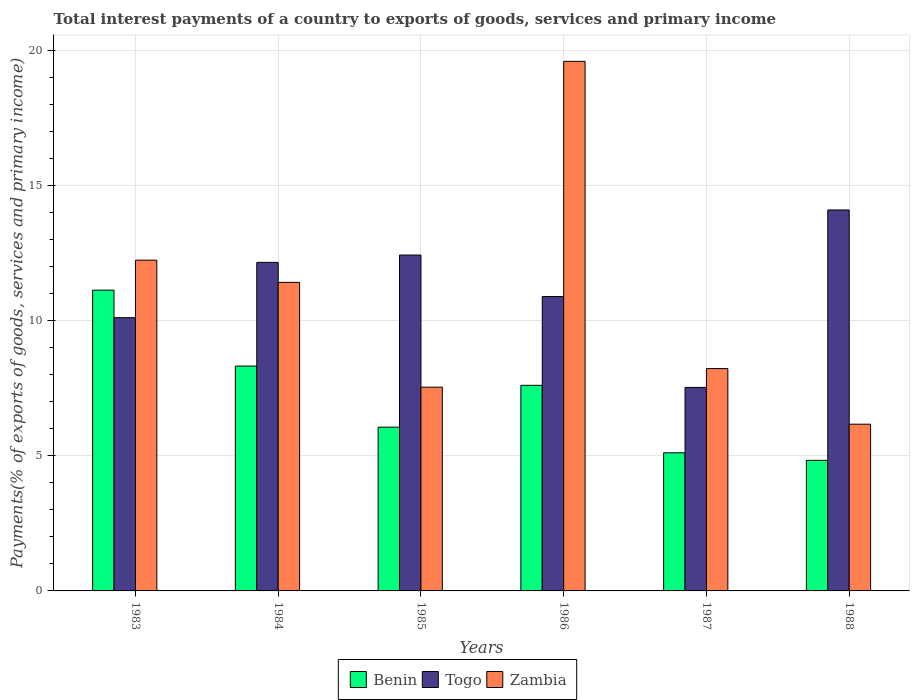How many different coloured bars are there?
Your answer should be compact. 3. Are the number of bars on each tick of the X-axis equal?
Your response must be concise. Yes. How many bars are there on the 4th tick from the left?
Give a very brief answer. 3. How many bars are there on the 4th tick from the right?
Provide a succinct answer. 3. In how many cases, is the number of bars for a given year not equal to the number of legend labels?
Ensure brevity in your answer.  0. What is the total interest payments in Zambia in 1983?
Your answer should be very brief. 12.25. Across all years, what is the maximum total interest payments in Togo?
Keep it short and to the point. 14.1. Across all years, what is the minimum total interest payments in Togo?
Offer a terse response. 7.53. In which year was the total interest payments in Zambia minimum?
Keep it short and to the point. 1988. What is the total total interest payments in Togo in the graph?
Make the answer very short. 67.25. What is the difference between the total interest payments in Zambia in 1986 and that in 1988?
Ensure brevity in your answer.  13.43. What is the difference between the total interest payments in Togo in 1988 and the total interest payments in Benin in 1985?
Keep it short and to the point. 8.04. What is the average total interest payments in Benin per year?
Provide a short and direct response. 7.18. In the year 1988, what is the difference between the total interest payments in Togo and total interest payments in Zambia?
Offer a terse response. 7.93. What is the ratio of the total interest payments in Zambia in 1983 to that in 1984?
Make the answer very short. 1.07. What is the difference between the highest and the second highest total interest payments in Zambia?
Ensure brevity in your answer.  7.36. What is the difference between the highest and the lowest total interest payments in Zambia?
Provide a succinct answer. 13.43. What does the 2nd bar from the left in 1983 represents?
Provide a short and direct response. Togo. What does the 3rd bar from the right in 1985 represents?
Make the answer very short. Benin. How many bars are there?
Ensure brevity in your answer.  18. Are all the bars in the graph horizontal?
Your answer should be very brief. No. What is the difference between two consecutive major ticks on the Y-axis?
Offer a very short reply. 5. Are the values on the major ticks of Y-axis written in scientific E-notation?
Give a very brief answer. No. Does the graph contain any zero values?
Provide a short and direct response. No. Does the graph contain grids?
Offer a very short reply. Yes. Where does the legend appear in the graph?
Your response must be concise. Bottom center. How many legend labels are there?
Your answer should be very brief. 3. How are the legend labels stacked?
Your answer should be compact. Horizontal. What is the title of the graph?
Your answer should be compact. Total interest payments of a country to exports of goods, services and primary income. Does "Latin America(developing only)" appear as one of the legend labels in the graph?
Keep it short and to the point. No. What is the label or title of the Y-axis?
Your answer should be very brief. Payments(% of exports of goods, services and primary income). What is the Payments(% of exports of goods, services and primary income) in Benin in 1983?
Offer a very short reply. 11.14. What is the Payments(% of exports of goods, services and primary income) in Togo in 1983?
Your answer should be very brief. 10.12. What is the Payments(% of exports of goods, services and primary income) of Zambia in 1983?
Keep it short and to the point. 12.25. What is the Payments(% of exports of goods, services and primary income) of Benin in 1984?
Provide a short and direct response. 8.33. What is the Payments(% of exports of goods, services and primary income) in Togo in 1984?
Provide a short and direct response. 12.16. What is the Payments(% of exports of goods, services and primary income) of Zambia in 1984?
Give a very brief answer. 11.42. What is the Payments(% of exports of goods, services and primary income) of Benin in 1985?
Give a very brief answer. 6.06. What is the Payments(% of exports of goods, services and primary income) in Togo in 1985?
Provide a short and direct response. 12.44. What is the Payments(% of exports of goods, services and primary income) in Zambia in 1985?
Ensure brevity in your answer.  7.54. What is the Payments(% of exports of goods, services and primary income) in Benin in 1986?
Your answer should be very brief. 7.61. What is the Payments(% of exports of goods, services and primary income) of Togo in 1986?
Your answer should be very brief. 10.9. What is the Payments(% of exports of goods, services and primary income) in Zambia in 1986?
Offer a very short reply. 19.61. What is the Payments(% of exports of goods, services and primary income) in Benin in 1987?
Give a very brief answer. 5.11. What is the Payments(% of exports of goods, services and primary income) of Togo in 1987?
Your answer should be very brief. 7.53. What is the Payments(% of exports of goods, services and primary income) of Zambia in 1987?
Your response must be concise. 8.23. What is the Payments(% of exports of goods, services and primary income) of Benin in 1988?
Your answer should be very brief. 4.83. What is the Payments(% of exports of goods, services and primary income) of Togo in 1988?
Offer a terse response. 14.1. What is the Payments(% of exports of goods, services and primary income) in Zambia in 1988?
Keep it short and to the point. 6.17. Across all years, what is the maximum Payments(% of exports of goods, services and primary income) of Benin?
Ensure brevity in your answer.  11.14. Across all years, what is the maximum Payments(% of exports of goods, services and primary income) in Togo?
Provide a succinct answer. 14.1. Across all years, what is the maximum Payments(% of exports of goods, services and primary income) in Zambia?
Provide a short and direct response. 19.61. Across all years, what is the minimum Payments(% of exports of goods, services and primary income) of Benin?
Keep it short and to the point. 4.83. Across all years, what is the minimum Payments(% of exports of goods, services and primary income) in Togo?
Give a very brief answer. 7.53. Across all years, what is the minimum Payments(% of exports of goods, services and primary income) of Zambia?
Ensure brevity in your answer.  6.17. What is the total Payments(% of exports of goods, services and primary income) in Benin in the graph?
Ensure brevity in your answer.  43.08. What is the total Payments(% of exports of goods, services and primary income) of Togo in the graph?
Your response must be concise. 67.25. What is the total Payments(% of exports of goods, services and primary income) of Zambia in the graph?
Your response must be concise. 65.22. What is the difference between the Payments(% of exports of goods, services and primary income) in Benin in 1983 and that in 1984?
Provide a succinct answer. 2.81. What is the difference between the Payments(% of exports of goods, services and primary income) of Togo in 1983 and that in 1984?
Provide a short and direct response. -2.05. What is the difference between the Payments(% of exports of goods, services and primary income) in Zambia in 1983 and that in 1984?
Offer a terse response. 0.82. What is the difference between the Payments(% of exports of goods, services and primary income) in Benin in 1983 and that in 1985?
Your response must be concise. 5.07. What is the difference between the Payments(% of exports of goods, services and primary income) of Togo in 1983 and that in 1985?
Make the answer very short. -2.32. What is the difference between the Payments(% of exports of goods, services and primary income) of Zambia in 1983 and that in 1985?
Give a very brief answer. 4.7. What is the difference between the Payments(% of exports of goods, services and primary income) in Benin in 1983 and that in 1986?
Make the answer very short. 3.52. What is the difference between the Payments(% of exports of goods, services and primary income) in Togo in 1983 and that in 1986?
Make the answer very short. -0.78. What is the difference between the Payments(% of exports of goods, services and primary income) of Zambia in 1983 and that in 1986?
Ensure brevity in your answer.  -7.36. What is the difference between the Payments(% of exports of goods, services and primary income) of Benin in 1983 and that in 1987?
Offer a very short reply. 6.02. What is the difference between the Payments(% of exports of goods, services and primary income) in Togo in 1983 and that in 1987?
Provide a succinct answer. 2.58. What is the difference between the Payments(% of exports of goods, services and primary income) in Zambia in 1983 and that in 1987?
Provide a short and direct response. 4.01. What is the difference between the Payments(% of exports of goods, services and primary income) of Benin in 1983 and that in 1988?
Provide a succinct answer. 6.3. What is the difference between the Payments(% of exports of goods, services and primary income) in Togo in 1983 and that in 1988?
Your answer should be very brief. -3.99. What is the difference between the Payments(% of exports of goods, services and primary income) of Zambia in 1983 and that in 1988?
Your response must be concise. 6.07. What is the difference between the Payments(% of exports of goods, services and primary income) in Benin in 1984 and that in 1985?
Your answer should be compact. 2.26. What is the difference between the Payments(% of exports of goods, services and primary income) in Togo in 1984 and that in 1985?
Keep it short and to the point. -0.27. What is the difference between the Payments(% of exports of goods, services and primary income) in Zambia in 1984 and that in 1985?
Offer a terse response. 3.88. What is the difference between the Payments(% of exports of goods, services and primary income) of Benin in 1984 and that in 1986?
Your answer should be very brief. 0.71. What is the difference between the Payments(% of exports of goods, services and primary income) of Togo in 1984 and that in 1986?
Ensure brevity in your answer.  1.27. What is the difference between the Payments(% of exports of goods, services and primary income) of Zambia in 1984 and that in 1986?
Your answer should be very brief. -8.18. What is the difference between the Payments(% of exports of goods, services and primary income) in Benin in 1984 and that in 1987?
Your answer should be compact. 3.21. What is the difference between the Payments(% of exports of goods, services and primary income) in Togo in 1984 and that in 1987?
Provide a succinct answer. 4.63. What is the difference between the Payments(% of exports of goods, services and primary income) of Zambia in 1984 and that in 1987?
Your answer should be compact. 3.19. What is the difference between the Payments(% of exports of goods, services and primary income) of Benin in 1984 and that in 1988?
Provide a short and direct response. 3.49. What is the difference between the Payments(% of exports of goods, services and primary income) of Togo in 1984 and that in 1988?
Keep it short and to the point. -1.94. What is the difference between the Payments(% of exports of goods, services and primary income) of Zambia in 1984 and that in 1988?
Offer a terse response. 5.25. What is the difference between the Payments(% of exports of goods, services and primary income) in Benin in 1985 and that in 1986?
Make the answer very short. -1.55. What is the difference between the Payments(% of exports of goods, services and primary income) of Togo in 1985 and that in 1986?
Ensure brevity in your answer.  1.54. What is the difference between the Payments(% of exports of goods, services and primary income) in Zambia in 1985 and that in 1986?
Offer a terse response. -12.06. What is the difference between the Payments(% of exports of goods, services and primary income) of Benin in 1985 and that in 1987?
Your answer should be very brief. 0.95. What is the difference between the Payments(% of exports of goods, services and primary income) in Togo in 1985 and that in 1987?
Give a very brief answer. 4.9. What is the difference between the Payments(% of exports of goods, services and primary income) of Zambia in 1985 and that in 1987?
Keep it short and to the point. -0.69. What is the difference between the Payments(% of exports of goods, services and primary income) of Benin in 1985 and that in 1988?
Your answer should be very brief. 1.23. What is the difference between the Payments(% of exports of goods, services and primary income) in Togo in 1985 and that in 1988?
Offer a very short reply. -1.67. What is the difference between the Payments(% of exports of goods, services and primary income) of Zambia in 1985 and that in 1988?
Your answer should be compact. 1.37. What is the difference between the Payments(% of exports of goods, services and primary income) of Benin in 1986 and that in 1987?
Your answer should be compact. 2.5. What is the difference between the Payments(% of exports of goods, services and primary income) of Togo in 1986 and that in 1987?
Offer a terse response. 3.36. What is the difference between the Payments(% of exports of goods, services and primary income) of Zambia in 1986 and that in 1987?
Give a very brief answer. 11.37. What is the difference between the Payments(% of exports of goods, services and primary income) of Benin in 1986 and that in 1988?
Provide a succinct answer. 2.78. What is the difference between the Payments(% of exports of goods, services and primary income) in Togo in 1986 and that in 1988?
Your answer should be very brief. -3.21. What is the difference between the Payments(% of exports of goods, services and primary income) in Zambia in 1986 and that in 1988?
Give a very brief answer. 13.43. What is the difference between the Payments(% of exports of goods, services and primary income) in Benin in 1987 and that in 1988?
Your answer should be compact. 0.28. What is the difference between the Payments(% of exports of goods, services and primary income) in Togo in 1987 and that in 1988?
Keep it short and to the point. -6.57. What is the difference between the Payments(% of exports of goods, services and primary income) of Zambia in 1987 and that in 1988?
Make the answer very short. 2.06. What is the difference between the Payments(% of exports of goods, services and primary income) of Benin in 1983 and the Payments(% of exports of goods, services and primary income) of Togo in 1984?
Your answer should be very brief. -1.03. What is the difference between the Payments(% of exports of goods, services and primary income) of Benin in 1983 and the Payments(% of exports of goods, services and primary income) of Zambia in 1984?
Ensure brevity in your answer.  -0.29. What is the difference between the Payments(% of exports of goods, services and primary income) of Togo in 1983 and the Payments(% of exports of goods, services and primary income) of Zambia in 1984?
Make the answer very short. -1.31. What is the difference between the Payments(% of exports of goods, services and primary income) in Benin in 1983 and the Payments(% of exports of goods, services and primary income) in Togo in 1985?
Give a very brief answer. -1.3. What is the difference between the Payments(% of exports of goods, services and primary income) in Benin in 1983 and the Payments(% of exports of goods, services and primary income) in Zambia in 1985?
Make the answer very short. 3.59. What is the difference between the Payments(% of exports of goods, services and primary income) of Togo in 1983 and the Payments(% of exports of goods, services and primary income) of Zambia in 1985?
Offer a terse response. 2.57. What is the difference between the Payments(% of exports of goods, services and primary income) of Benin in 1983 and the Payments(% of exports of goods, services and primary income) of Togo in 1986?
Provide a short and direct response. 0.24. What is the difference between the Payments(% of exports of goods, services and primary income) of Benin in 1983 and the Payments(% of exports of goods, services and primary income) of Zambia in 1986?
Provide a succinct answer. -8.47. What is the difference between the Payments(% of exports of goods, services and primary income) in Togo in 1983 and the Payments(% of exports of goods, services and primary income) in Zambia in 1986?
Offer a terse response. -9.49. What is the difference between the Payments(% of exports of goods, services and primary income) in Benin in 1983 and the Payments(% of exports of goods, services and primary income) in Togo in 1987?
Keep it short and to the point. 3.6. What is the difference between the Payments(% of exports of goods, services and primary income) in Benin in 1983 and the Payments(% of exports of goods, services and primary income) in Zambia in 1987?
Offer a very short reply. 2.9. What is the difference between the Payments(% of exports of goods, services and primary income) in Togo in 1983 and the Payments(% of exports of goods, services and primary income) in Zambia in 1987?
Your answer should be compact. 1.88. What is the difference between the Payments(% of exports of goods, services and primary income) in Benin in 1983 and the Payments(% of exports of goods, services and primary income) in Togo in 1988?
Make the answer very short. -2.97. What is the difference between the Payments(% of exports of goods, services and primary income) in Benin in 1983 and the Payments(% of exports of goods, services and primary income) in Zambia in 1988?
Provide a short and direct response. 4.96. What is the difference between the Payments(% of exports of goods, services and primary income) in Togo in 1983 and the Payments(% of exports of goods, services and primary income) in Zambia in 1988?
Your response must be concise. 3.94. What is the difference between the Payments(% of exports of goods, services and primary income) of Benin in 1984 and the Payments(% of exports of goods, services and primary income) of Togo in 1985?
Provide a short and direct response. -4.11. What is the difference between the Payments(% of exports of goods, services and primary income) in Benin in 1984 and the Payments(% of exports of goods, services and primary income) in Zambia in 1985?
Give a very brief answer. 0.78. What is the difference between the Payments(% of exports of goods, services and primary income) in Togo in 1984 and the Payments(% of exports of goods, services and primary income) in Zambia in 1985?
Ensure brevity in your answer.  4.62. What is the difference between the Payments(% of exports of goods, services and primary income) in Benin in 1984 and the Payments(% of exports of goods, services and primary income) in Togo in 1986?
Provide a short and direct response. -2.57. What is the difference between the Payments(% of exports of goods, services and primary income) in Benin in 1984 and the Payments(% of exports of goods, services and primary income) in Zambia in 1986?
Your answer should be compact. -11.28. What is the difference between the Payments(% of exports of goods, services and primary income) of Togo in 1984 and the Payments(% of exports of goods, services and primary income) of Zambia in 1986?
Offer a terse response. -7.44. What is the difference between the Payments(% of exports of goods, services and primary income) of Benin in 1984 and the Payments(% of exports of goods, services and primary income) of Togo in 1987?
Ensure brevity in your answer.  0.79. What is the difference between the Payments(% of exports of goods, services and primary income) of Benin in 1984 and the Payments(% of exports of goods, services and primary income) of Zambia in 1987?
Your answer should be very brief. 0.09. What is the difference between the Payments(% of exports of goods, services and primary income) in Togo in 1984 and the Payments(% of exports of goods, services and primary income) in Zambia in 1987?
Ensure brevity in your answer.  3.93. What is the difference between the Payments(% of exports of goods, services and primary income) of Benin in 1984 and the Payments(% of exports of goods, services and primary income) of Togo in 1988?
Provide a succinct answer. -5.78. What is the difference between the Payments(% of exports of goods, services and primary income) in Benin in 1984 and the Payments(% of exports of goods, services and primary income) in Zambia in 1988?
Give a very brief answer. 2.15. What is the difference between the Payments(% of exports of goods, services and primary income) of Togo in 1984 and the Payments(% of exports of goods, services and primary income) of Zambia in 1988?
Offer a terse response. 5.99. What is the difference between the Payments(% of exports of goods, services and primary income) of Benin in 1985 and the Payments(% of exports of goods, services and primary income) of Togo in 1986?
Give a very brief answer. -4.83. What is the difference between the Payments(% of exports of goods, services and primary income) of Benin in 1985 and the Payments(% of exports of goods, services and primary income) of Zambia in 1986?
Give a very brief answer. -13.54. What is the difference between the Payments(% of exports of goods, services and primary income) in Togo in 1985 and the Payments(% of exports of goods, services and primary income) in Zambia in 1986?
Offer a very short reply. -7.17. What is the difference between the Payments(% of exports of goods, services and primary income) in Benin in 1985 and the Payments(% of exports of goods, services and primary income) in Togo in 1987?
Give a very brief answer. -1.47. What is the difference between the Payments(% of exports of goods, services and primary income) in Benin in 1985 and the Payments(% of exports of goods, services and primary income) in Zambia in 1987?
Give a very brief answer. -2.17. What is the difference between the Payments(% of exports of goods, services and primary income) of Togo in 1985 and the Payments(% of exports of goods, services and primary income) of Zambia in 1987?
Your response must be concise. 4.2. What is the difference between the Payments(% of exports of goods, services and primary income) of Benin in 1985 and the Payments(% of exports of goods, services and primary income) of Togo in 1988?
Offer a very short reply. -8.04. What is the difference between the Payments(% of exports of goods, services and primary income) in Benin in 1985 and the Payments(% of exports of goods, services and primary income) in Zambia in 1988?
Make the answer very short. -0.11. What is the difference between the Payments(% of exports of goods, services and primary income) in Togo in 1985 and the Payments(% of exports of goods, services and primary income) in Zambia in 1988?
Provide a succinct answer. 6.26. What is the difference between the Payments(% of exports of goods, services and primary income) of Benin in 1986 and the Payments(% of exports of goods, services and primary income) of Togo in 1987?
Your answer should be very brief. 0.08. What is the difference between the Payments(% of exports of goods, services and primary income) of Benin in 1986 and the Payments(% of exports of goods, services and primary income) of Zambia in 1987?
Provide a short and direct response. -0.62. What is the difference between the Payments(% of exports of goods, services and primary income) of Togo in 1986 and the Payments(% of exports of goods, services and primary income) of Zambia in 1987?
Offer a terse response. 2.67. What is the difference between the Payments(% of exports of goods, services and primary income) of Benin in 1986 and the Payments(% of exports of goods, services and primary income) of Togo in 1988?
Offer a terse response. -6.49. What is the difference between the Payments(% of exports of goods, services and primary income) in Benin in 1986 and the Payments(% of exports of goods, services and primary income) in Zambia in 1988?
Your answer should be compact. 1.44. What is the difference between the Payments(% of exports of goods, services and primary income) of Togo in 1986 and the Payments(% of exports of goods, services and primary income) of Zambia in 1988?
Provide a short and direct response. 4.72. What is the difference between the Payments(% of exports of goods, services and primary income) of Benin in 1987 and the Payments(% of exports of goods, services and primary income) of Togo in 1988?
Keep it short and to the point. -8.99. What is the difference between the Payments(% of exports of goods, services and primary income) in Benin in 1987 and the Payments(% of exports of goods, services and primary income) in Zambia in 1988?
Offer a very short reply. -1.06. What is the difference between the Payments(% of exports of goods, services and primary income) in Togo in 1987 and the Payments(% of exports of goods, services and primary income) in Zambia in 1988?
Your answer should be very brief. 1.36. What is the average Payments(% of exports of goods, services and primary income) of Benin per year?
Your answer should be compact. 7.18. What is the average Payments(% of exports of goods, services and primary income) of Togo per year?
Your answer should be very brief. 11.21. What is the average Payments(% of exports of goods, services and primary income) in Zambia per year?
Give a very brief answer. 10.87. In the year 1983, what is the difference between the Payments(% of exports of goods, services and primary income) in Benin and Payments(% of exports of goods, services and primary income) in Togo?
Make the answer very short. 1.02. In the year 1983, what is the difference between the Payments(% of exports of goods, services and primary income) of Benin and Payments(% of exports of goods, services and primary income) of Zambia?
Your answer should be compact. -1.11. In the year 1983, what is the difference between the Payments(% of exports of goods, services and primary income) in Togo and Payments(% of exports of goods, services and primary income) in Zambia?
Provide a short and direct response. -2.13. In the year 1984, what is the difference between the Payments(% of exports of goods, services and primary income) in Benin and Payments(% of exports of goods, services and primary income) in Togo?
Provide a short and direct response. -3.84. In the year 1984, what is the difference between the Payments(% of exports of goods, services and primary income) of Benin and Payments(% of exports of goods, services and primary income) of Zambia?
Keep it short and to the point. -3.1. In the year 1984, what is the difference between the Payments(% of exports of goods, services and primary income) in Togo and Payments(% of exports of goods, services and primary income) in Zambia?
Offer a terse response. 0.74. In the year 1985, what is the difference between the Payments(% of exports of goods, services and primary income) of Benin and Payments(% of exports of goods, services and primary income) of Togo?
Give a very brief answer. -6.37. In the year 1985, what is the difference between the Payments(% of exports of goods, services and primary income) in Benin and Payments(% of exports of goods, services and primary income) in Zambia?
Your answer should be very brief. -1.48. In the year 1985, what is the difference between the Payments(% of exports of goods, services and primary income) in Togo and Payments(% of exports of goods, services and primary income) in Zambia?
Ensure brevity in your answer.  4.89. In the year 1986, what is the difference between the Payments(% of exports of goods, services and primary income) in Benin and Payments(% of exports of goods, services and primary income) in Togo?
Provide a succinct answer. -3.29. In the year 1986, what is the difference between the Payments(% of exports of goods, services and primary income) of Benin and Payments(% of exports of goods, services and primary income) of Zambia?
Provide a succinct answer. -11.99. In the year 1986, what is the difference between the Payments(% of exports of goods, services and primary income) of Togo and Payments(% of exports of goods, services and primary income) of Zambia?
Keep it short and to the point. -8.71. In the year 1987, what is the difference between the Payments(% of exports of goods, services and primary income) of Benin and Payments(% of exports of goods, services and primary income) of Togo?
Make the answer very short. -2.42. In the year 1987, what is the difference between the Payments(% of exports of goods, services and primary income) of Benin and Payments(% of exports of goods, services and primary income) of Zambia?
Provide a succinct answer. -3.12. In the year 1987, what is the difference between the Payments(% of exports of goods, services and primary income) of Togo and Payments(% of exports of goods, services and primary income) of Zambia?
Your answer should be very brief. -0.7. In the year 1988, what is the difference between the Payments(% of exports of goods, services and primary income) of Benin and Payments(% of exports of goods, services and primary income) of Togo?
Your answer should be very brief. -9.27. In the year 1988, what is the difference between the Payments(% of exports of goods, services and primary income) in Benin and Payments(% of exports of goods, services and primary income) in Zambia?
Offer a terse response. -1.34. In the year 1988, what is the difference between the Payments(% of exports of goods, services and primary income) in Togo and Payments(% of exports of goods, services and primary income) in Zambia?
Your answer should be compact. 7.93. What is the ratio of the Payments(% of exports of goods, services and primary income) in Benin in 1983 to that in 1984?
Provide a succinct answer. 1.34. What is the ratio of the Payments(% of exports of goods, services and primary income) of Togo in 1983 to that in 1984?
Your answer should be very brief. 0.83. What is the ratio of the Payments(% of exports of goods, services and primary income) in Zambia in 1983 to that in 1984?
Offer a terse response. 1.07. What is the ratio of the Payments(% of exports of goods, services and primary income) of Benin in 1983 to that in 1985?
Keep it short and to the point. 1.84. What is the ratio of the Payments(% of exports of goods, services and primary income) of Togo in 1983 to that in 1985?
Offer a very short reply. 0.81. What is the ratio of the Payments(% of exports of goods, services and primary income) in Zambia in 1983 to that in 1985?
Provide a succinct answer. 1.62. What is the ratio of the Payments(% of exports of goods, services and primary income) of Benin in 1983 to that in 1986?
Provide a short and direct response. 1.46. What is the ratio of the Payments(% of exports of goods, services and primary income) of Togo in 1983 to that in 1986?
Make the answer very short. 0.93. What is the ratio of the Payments(% of exports of goods, services and primary income) of Zambia in 1983 to that in 1986?
Make the answer very short. 0.62. What is the ratio of the Payments(% of exports of goods, services and primary income) of Benin in 1983 to that in 1987?
Keep it short and to the point. 2.18. What is the ratio of the Payments(% of exports of goods, services and primary income) of Togo in 1983 to that in 1987?
Your answer should be very brief. 1.34. What is the ratio of the Payments(% of exports of goods, services and primary income) in Zambia in 1983 to that in 1987?
Offer a very short reply. 1.49. What is the ratio of the Payments(% of exports of goods, services and primary income) of Benin in 1983 to that in 1988?
Your response must be concise. 2.3. What is the ratio of the Payments(% of exports of goods, services and primary income) in Togo in 1983 to that in 1988?
Provide a short and direct response. 0.72. What is the ratio of the Payments(% of exports of goods, services and primary income) of Zambia in 1983 to that in 1988?
Ensure brevity in your answer.  1.98. What is the ratio of the Payments(% of exports of goods, services and primary income) of Benin in 1984 to that in 1985?
Provide a short and direct response. 1.37. What is the ratio of the Payments(% of exports of goods, services and primary income) in Togo in 1984 to that in 1985?
Your answer should be compact. 0.98. What is the ratio of the Payments(% of exports of goods, services and primary income) of Zambia in 1984 to that in 1985?
Offer a very short reply. 1.51. What is the ratio of the Payments(% of exports of goods, services and primary income) of Benin in 1984 to that in 1986?
Your answer should be compact. 1.09. What is the ratio of the Payments(% of exports of goods, services and primary income) in Togo in 1984 to that in 1986?
Provide a succinct answer. 1.12. What is the ratio of the Payments(% of exports of goods, services and primary income) in Zambia in 1984 to that in 1986?
Provide a succinct answer. 0.58. What is the ratio of the Payments(% of exports of goods, services and primary income) in Benin in 1984 to that in 1987?
Your response must be concise. 1.63. What is the ratio of the Payments(% of exports of goods, services and primary income) in Togo in 1984 to that in 1987?
Your response must be concise. 1.61. What is the ratio of the Payments(% of exports of goods, services and primary income) in Zambia in 1984 to that in 1987?
Provide a succinct answer. 1.39. What is the ratio of the Payments(% of exports of goods, services and primary income) of Benin in 1984 to that in 1988?
Your answer should be compact. 1.72. What is the ratio of the Payments(% of exports of goods, services and primary income) of Togo in 1984 to that in 1988?
Make the answer very short. 0.86. What is the ratio of the Payments(% of exports of goods, services and primary income) of Zambia in 1984 to that in 1988?
Keep it short and to the point. 1.85. What is the ratio of the Payments(% of exports of goods, services and primary income) of Benin in 1985 to that in 1986?
Ensure brevity in your answer.  0.8. What is the ratio of the Payments(% of exports of goods, services and primary income) in Togo in 1985 to that in 1986?
Your answer should be very brief. 1.14. What is the ratio of the Payments(% of exports of goods, services and primary income) in Zambia in 1985 to that in 1986?
Provide a short and direct response. 0.38. What is the ratio of the Payments(% of exports of goods, services and primary income) of Benin in 1985 to that in 1987?
Your answer should be compact. 1.19. What is the ratio of the Payments(% of exports of goods, services and primary income) in Togo in 1985 to that in 1987?
Make the answer very short. 1.65. What is the ratio of the Payments(% of exports of goods, services and primary income) of Zambia in 1985 to that in 1987?
Your response must be concise. 0.92. What is the ratio of the Payments(% of exports of goods, services and primary income) in Benin in 1985 to that in 1988?
Ensure brevity in your answer.  1.25. What is the ratio of the Payments(% of exports of goods, services and primary income) of Togo in 1985 to that in 1988?
Provide a short and direct response. 0.88. What is the ratio of the Payments(% of exports of goods, services and primary income) of Zambia in 1985 to that in 1988?
Your response must be concise. 1.22. What is the ratio of the Payments(% of exports of goods, services and primary income) in Benin in 1986 to that in 1987?
Give a very brief answer. 1.49. What is the ratio of the Payments(% of exports of goods, services and primary income) in Togo in 1986 to that in 1987?
Your answer should be compact. 1.45. What is the ratio of the Payments(% of exports of goods, services and primary income) of Zambia in 1986 to that in 1987?
Provide a short and direct response. 2.38. What is the ratio of the Payments(% of exports of goods, services and primary income) of Benin in 1986 to that in 1988?
Your response must be concise. 1.57. What is the ratio of the Payments(% of exports of goods, services and primary income) in Togo in 1986 to that in 1988?
Ensure brevity in your answer.  0.77. What is the ratio of the Payments(% of exports of goods, services and primary income) of Zambia in 1986 to that in 1988?
Give a very brief answer. 3.18. What is the ratio of the Payments(% of exports of goods, services and primary income) in Benin in 1987 to that in 1988?
Keep it short and to the point. 1.06. What is the ratio of the Payments(% of exports of goods, services and primary income) of Togo in 1987 to that in 1988?
Ensure brevity in your answer.  0.53. What is the ratio of the Payments(% of exports of goods, services and primary income) of Zambia in 1987 to that in 1988?
Provide a succinct answer. 1.33. What is the difference between the highest and the second highest Payments(% of exports of goods, services and primary income) in Benin?
Your answer should be compact. 2.81. What is the difference between the highest and the second highest Payments(% of exports of goods, services and primary income) of Togo?
Offer a terse response. 1.67. What is the difference between the highest and the second highest Payments(% of exports of goods, services and primary income) in Zambia?
Provide a short and direct response. 7.36. What is the difference between the highest and the lowest Payments(% of exports of goods, services and primary income) of Benin?
Provide a succinct answer. 6.3. What is the difference between the highest and the lowest Payments(% of exports of goods, services and primary income) of Togo?
Offer a terse response. 6.57. What is the difference between the highest and the lowest Payments(% of exports of goods, services and primary income) of Zambia?
Give a very brief answer. 13.43. 